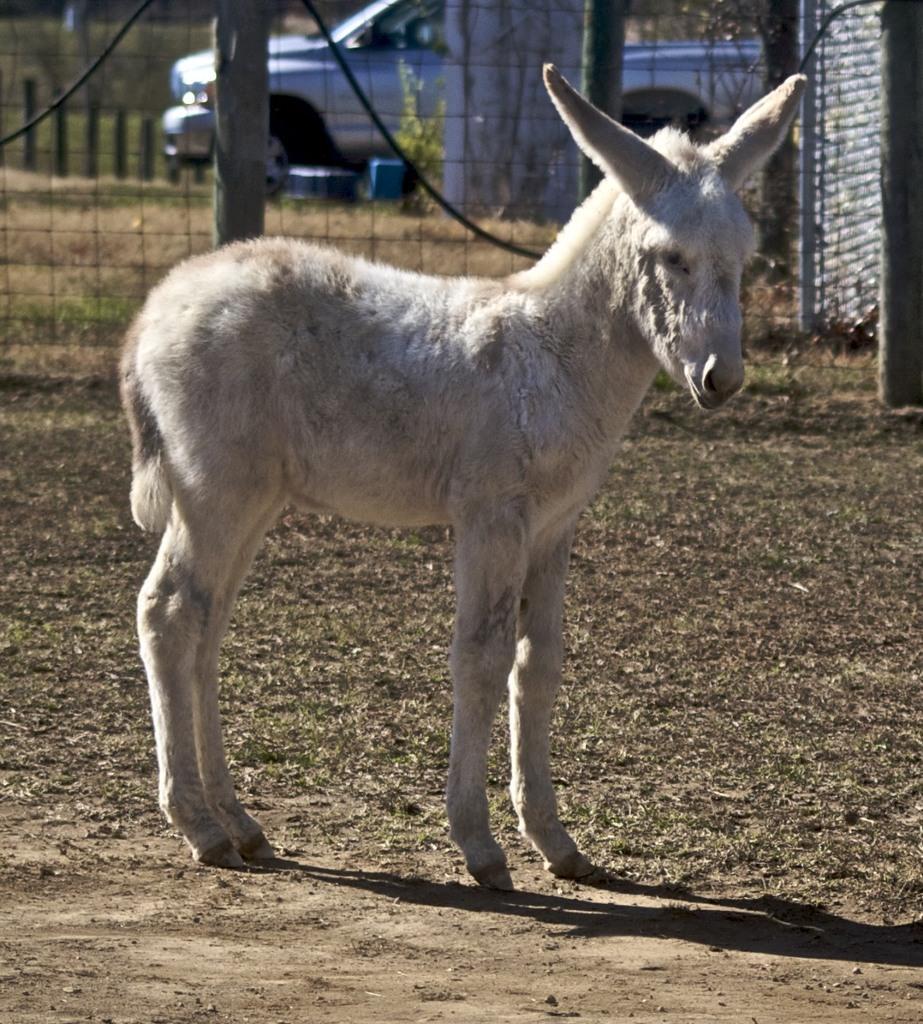How would you summarize this image in a sentence or two? In this image I can see an animal which is white in color is standing on the ground. In the background I can see the metal fencing and a vehicle on the ground. 